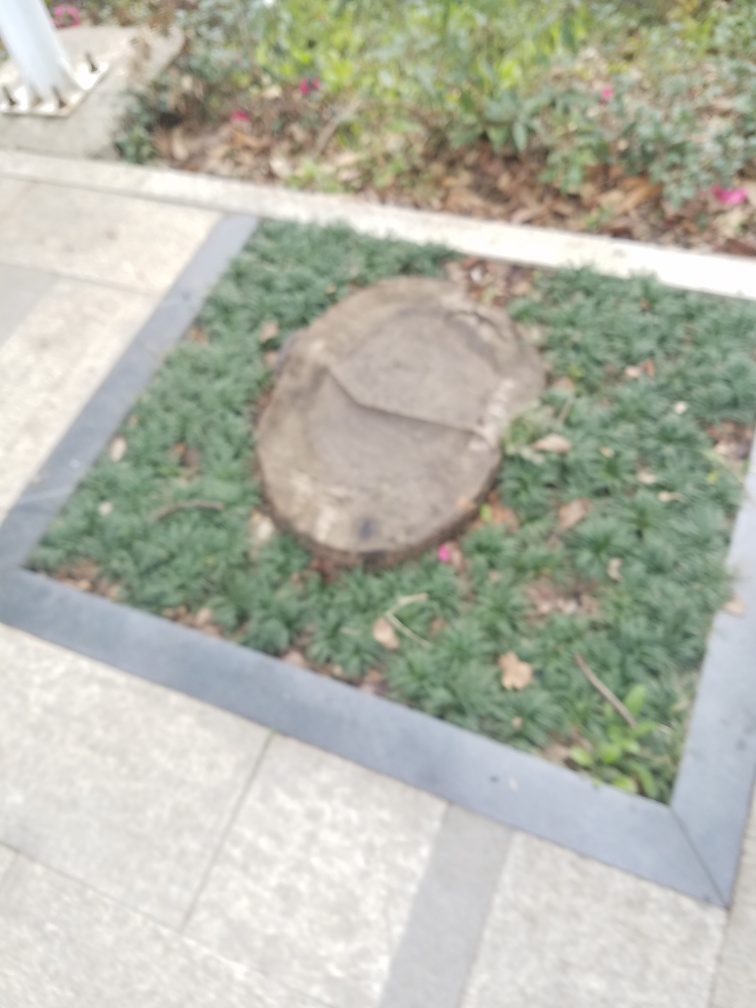Can you tell what time of day this photo was likely taken? Although the image is not clear, the soft and diffused lighting suggests that it might have been shot during the daytime, possibly in the morning or late afternoon when the light is not as harsh. 